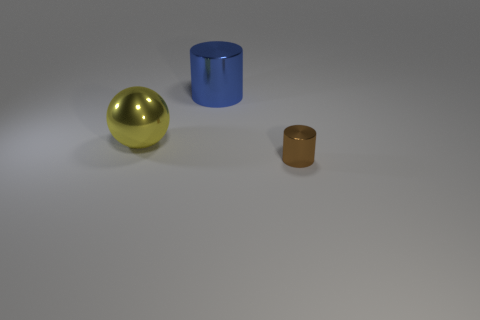Add 3 large green shiny cylinders. How many objects exist? 6 Subtract all balls. How many objects are left? 2 Subtract all tiny purple shiny spheres. Subtract all big metal objects. How many objects are left? 1 Add 2 yellow metallic spheres. How many yellow metallic spheres are left? 3 Add 1 big yellow matte cylinders. How many big yellow matte cylinders exist? 1 Subtract 0 yellow blocks. How many objects are left? 3 